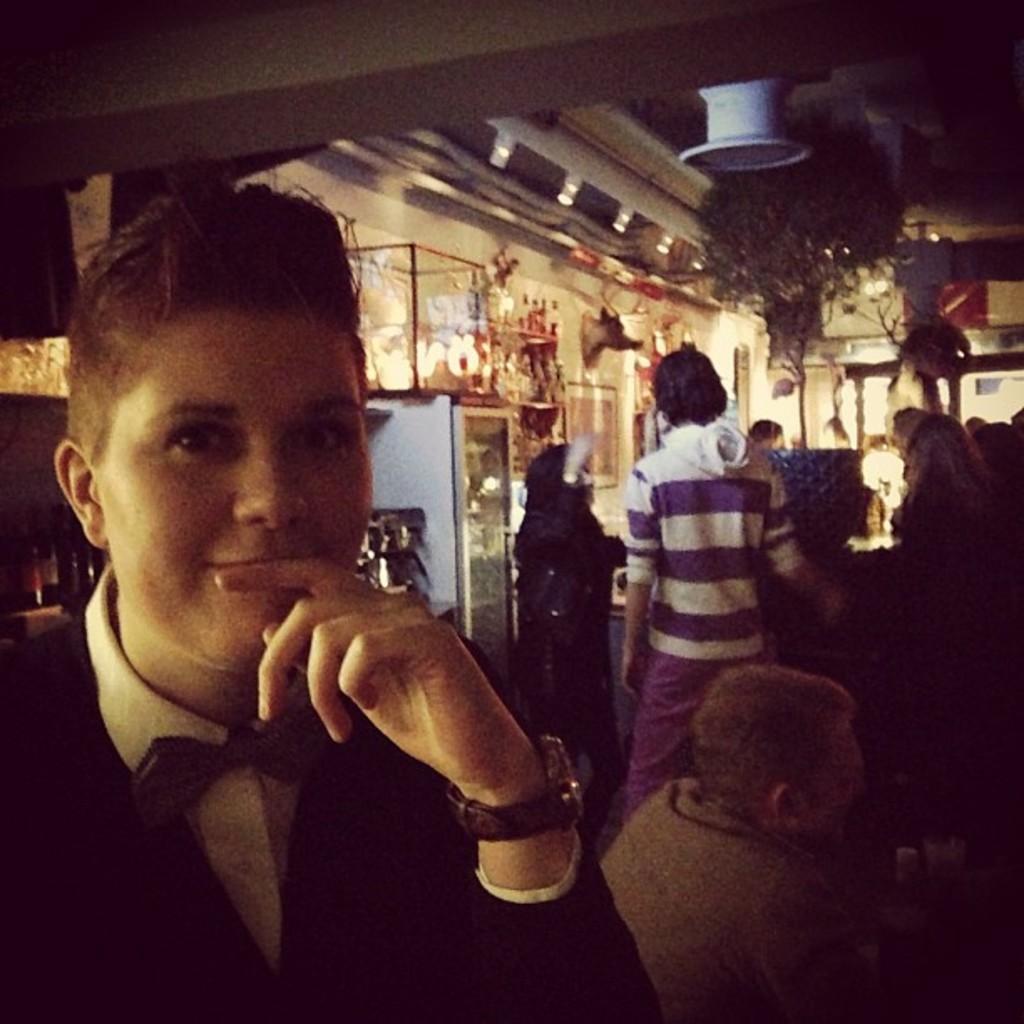In one or two sentences, can you explain what this image depicts? In this image, we can see people standing and some of them are sitting. In the background, there are stands, lights, trees and buildings. At the top, there is roof and we can see an object which is in white color. 